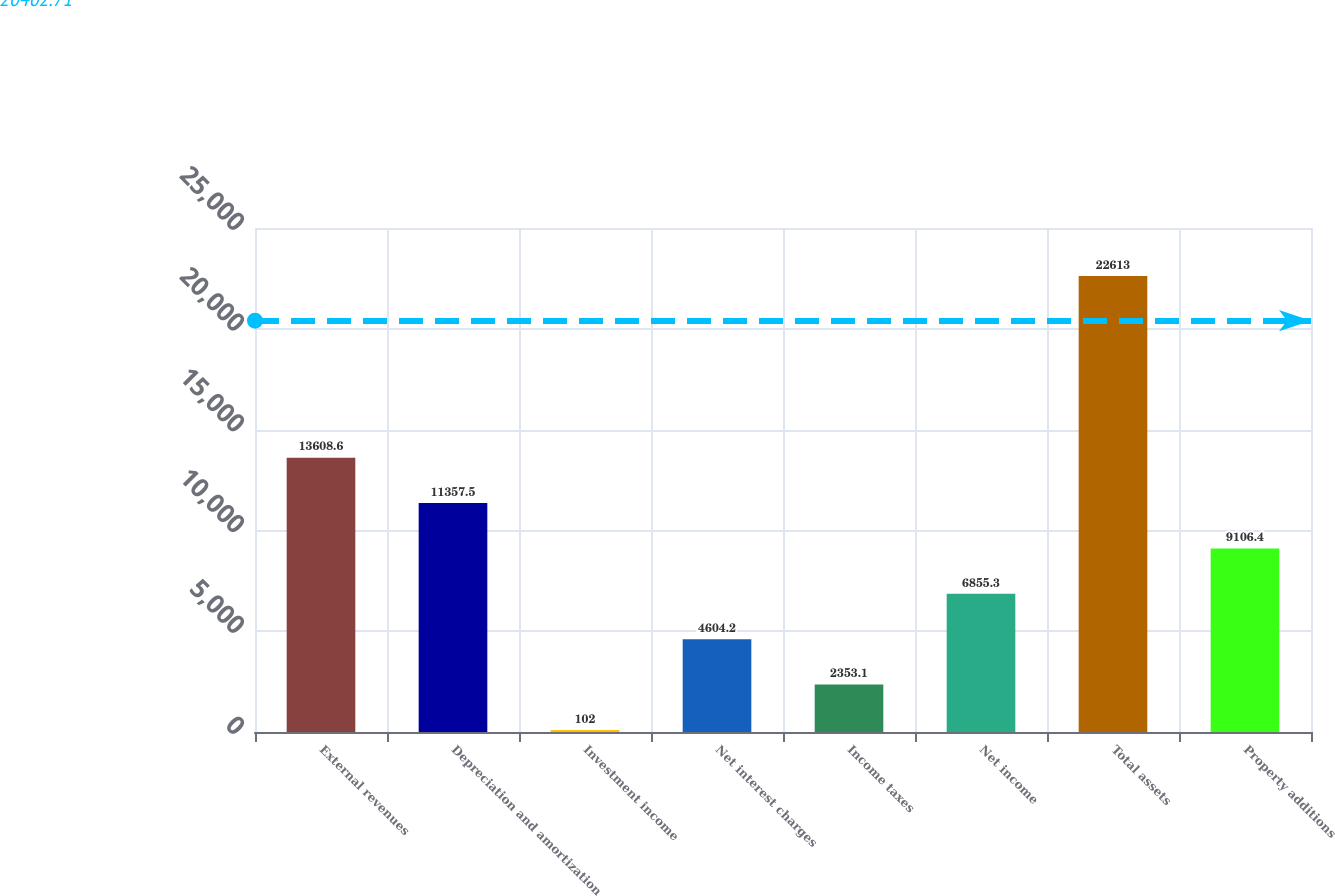Convert chart to OTSL. <chart><loc_0><loc_0><loc_500><loc_500><bar_chart><fcel>External revenues<fcel>Depreciation and amortization<fcel>Investment income<fcel>Net interest charges<fcel>Income taxes<fcel>Net income<fcel>Total assets<fcel>Property additions<nl><fcel>13608.6<fcel>11357.5<fcel>102<fcel>4604.2<fcel>2353.1<fcel>6855.3<fcel>22613<fcel>9106.4<nl></chart> 